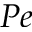<formula> <loc_0><loc_0><loc_500><loc_500>P e</formula> 